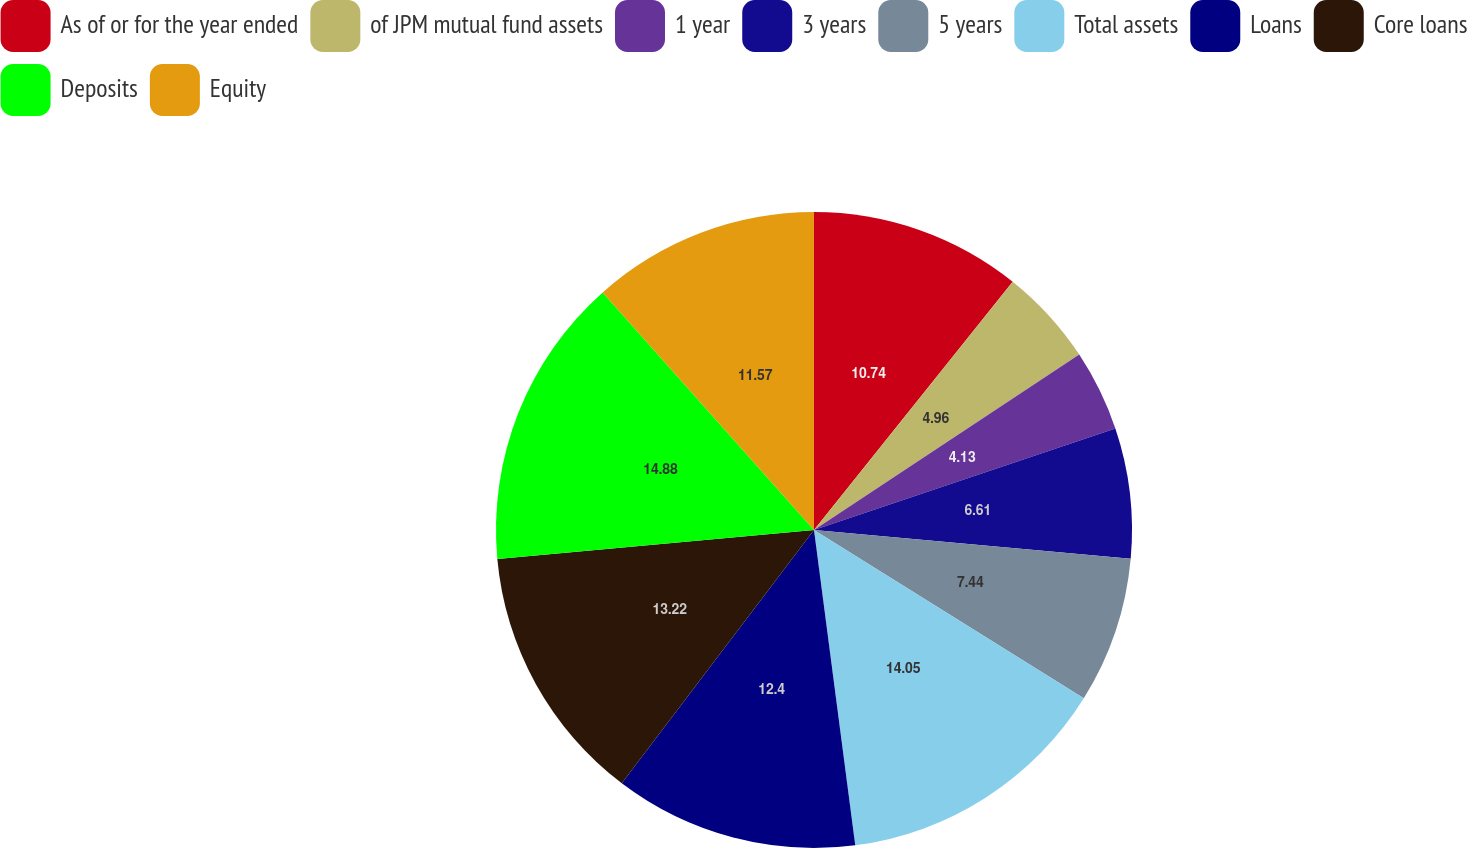Convert chart. <chart><loc_0><loc_0><loc_500><loc_500><pie_chart><fcel>As of or for the year ended<fcel>of JPM mutual fund assets<fcel>1 year<fcel>3 years<fcel>5 years<fcel>Total assets<fcel>Loans<fcel>Core loans<fcel>Deposits<fcel>Equity<nl><fcel>10.74%<fcel>4.96%<fcel>4.13%<fcel>6.61%<fcel>7.44%<fcel>14.05%<fcel>12.4%<fcel>13.22%<fcel>14.88%<fcel>11.57%<nl></chart> 